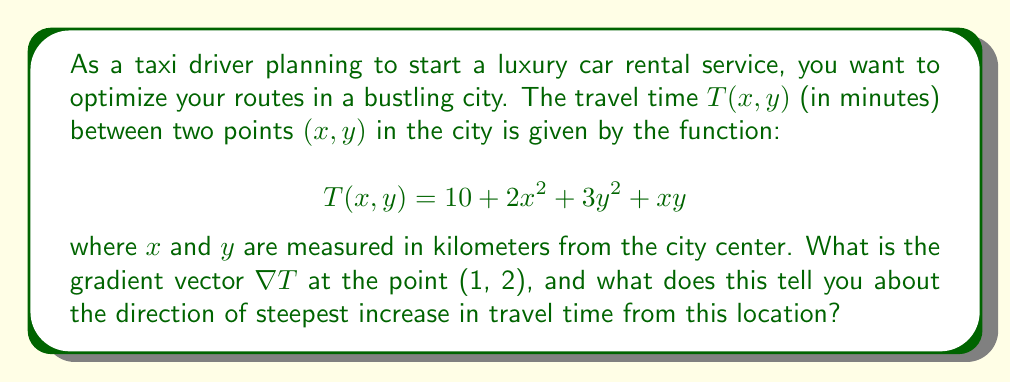Could you help me with this problem? To solve this problem, we need to follow these steps:

1) First, let's recall that the gradient vector $\nabla T$ for a function $T(x,y)$ is defined as:

   $$\nabla T = \left(\frac{\partial T}{\partial x}, \frac{\partial T}{\partial y}\right)$$

2) We need to calculate the partial derivatives $\frac{\partial T}{\partial x}$ and $\frac{\partial T}{\partial y}$:

   $$\frac{\partial T}{\partial x} = 4x + y$$
   $$\frac{\partial T}{\partial y} = 6y + x$$

3) Now, we can form the gradient vector:

   $$\nabla T = (4x + y, 6y + x)$$

4) We're asked to evaluate this at the point (1, 2). Let's substitute these values:

   $$\nabla T|_{(1,2)} = (4(1) + 2, 6(2) + 1) = (6, 13)$$

5) The gradient vector points in the direction of steepest increase of the function. Its magnitude indicates the rate of increase in that direction.

6) To interpret this result:
   - The vector (6, 13) points northeast from the point (1, 2).
   - This means that travel time increases most rapidly when moving in this direction from (1, 2).
   - The magnitude of this vector is $\sqrt{6^2 + 13^2} \approx 14.32$, indicating a rapid rate of increase in travel time in this direction.

This information is crucial for a taxi driver or luxury car rental service. It suggests that to minimize travel time, you should avoid routes that go northeast from the point (1, 2), as travel times increase most rapidly in that direction.
Answer: The gradient vector at the point (1, 2) is $\nabla T|_{(1,2)} = (6, 13)$. This indicates that the direction of steepest increase in travel time from (1, 2) is northeast, with a rapid rate of increase. 